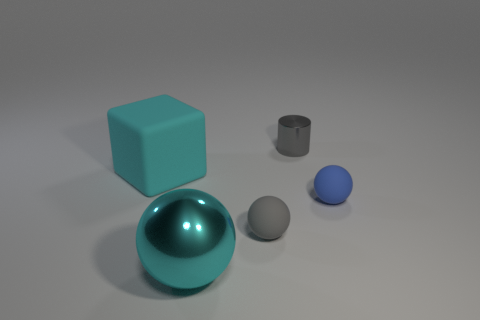Subtract all red cylinders. Subtract all gray spheres. How many cylinders are left? 1 Add 1 cyan matte cubes. How many objects exist? 6 Subtract all cylinders. How many objects are left? 4 Add 2 big cyan metal cubes. How many big cyan metal cubes exist? 2 Subtract 0 red blocks. How many objects are left? 5 Subtract all small blue objects. Subtract all cyan cubes. How many objects are left? 3 Add 2 tiny matte things. How many tiny matte things are left? 4 